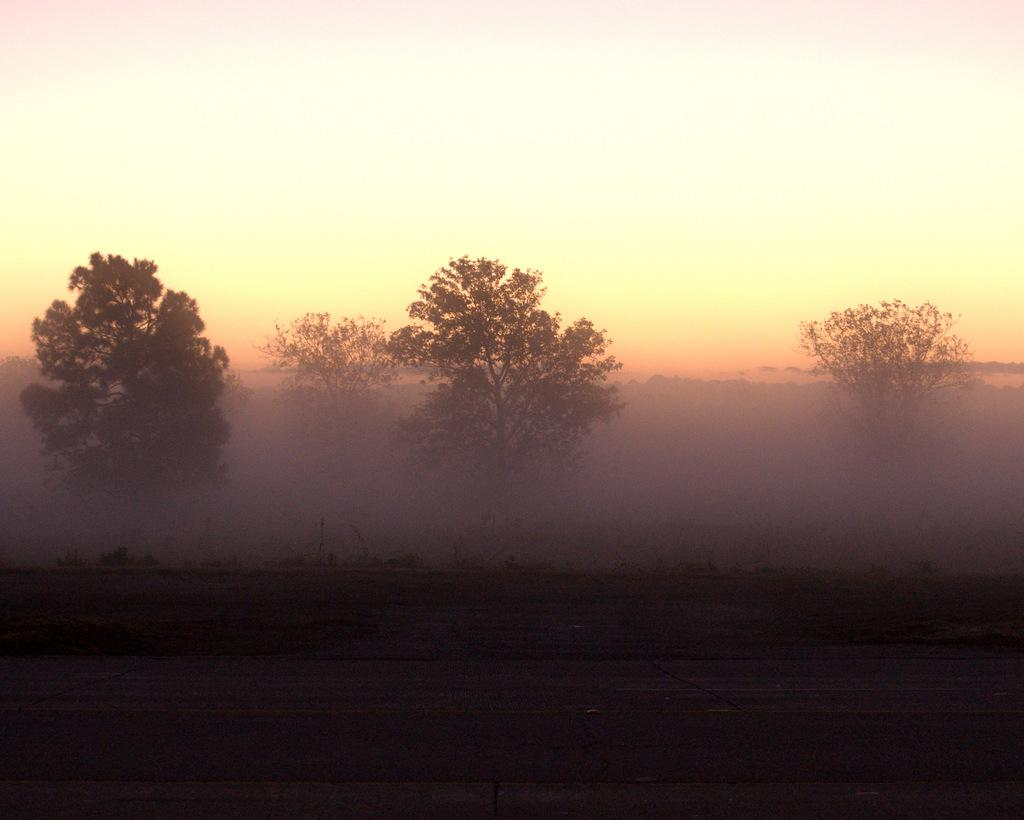What type of vegetation is present in the image? There are many trees in the image. What can be seen at the bottom of the image? There is a road visible at the bottom of the image. What weather condition is present on the right side of the image? Fog is present on the right side of the image. What is visible at the top of the image? The sky is visible at the top of the image. How many drawers are visible in the image? There are no drawers present in the image. What is the amount of fog visible in the image? The image does not specify an amount of fog; it only indicates that fog is present on the right side of the image. 